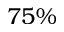Convert formula to latex. <formula><loc_0><loc_0><loc_500><loc_500>7 5 \%</formula> 